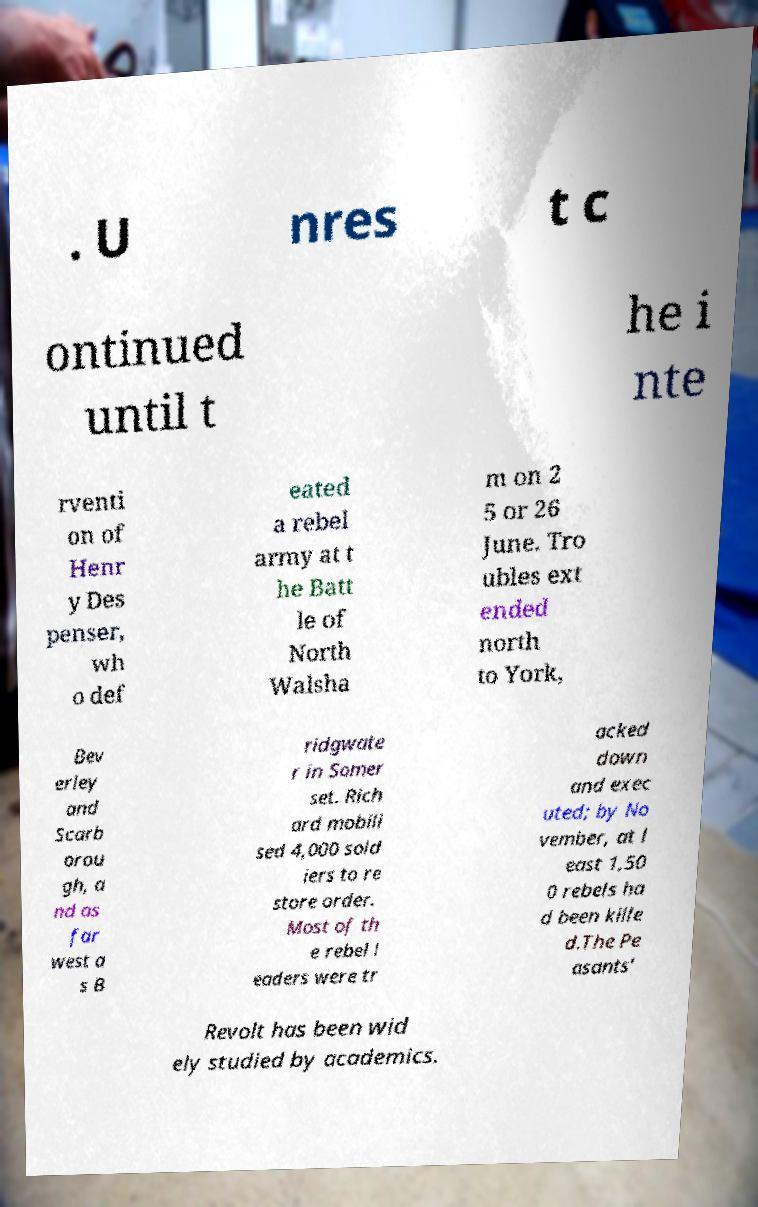Please read and relay the text visible in this image. What does it say? . U nres t c ontinued until t he i nte rventi on of Henr y Des penser, wh o def eated a rebel army at t he Batt le of North Walsha m on 2 5 or 26 June. Tro ubles ext ended north to York, Bev erley and Scarb orou gh, a nd as far west a s B ridgwate r in Somer set. Rich ard mobili sed 4,000 sold iers to re store order. Most of th e rebel l eaders were tr acked down and exec uted; by No vember, at l east 1,50 0 rebels ha d been kille d.The Pe asants' Revolt has been wid ely studied by academics. 